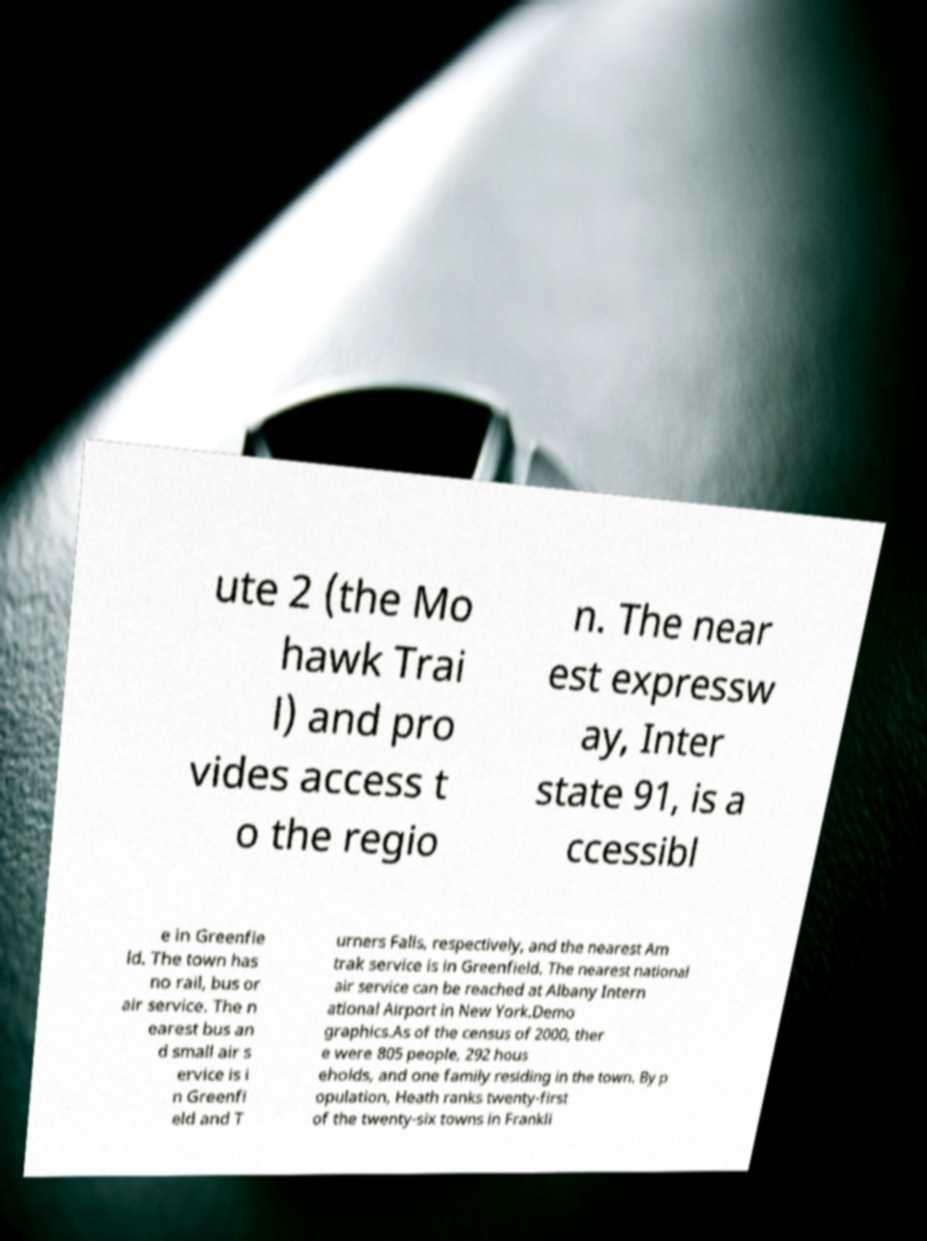Please read and relay the text visible in this image. What does it say? ute 2 (the Mo hawk Trai l) and pro vides access t o the regio n. The near est expressw ay, Inter state 91, is a ccessibl e in Greenfie ld. The town has no rail, bus or air service. The n earest bus an d small air s ervice is i n Greenfi eld and T urners Falls, respectively, and the nearest Am trak service is in Greenfield. The nearest national air service can be reached at Albany Intern ational Airport in New York.Demo graphics.As of the census of 2000, ther e were 805 people, 292 hous eholds, and one family residing in the town. By p opulation, Heath ranks twenty-first of the twenty-six towns in Frankli 